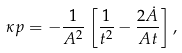<formula> <loc_0><loc_0><loc_500><loc_500>\kappa p = - \frac { 1 } { A ^ { 2 } } \left [ \frac { 1 } { t ^ { 2 } } - \frac { 2 \dot { A } } { A t } \right ] ,</formula> 